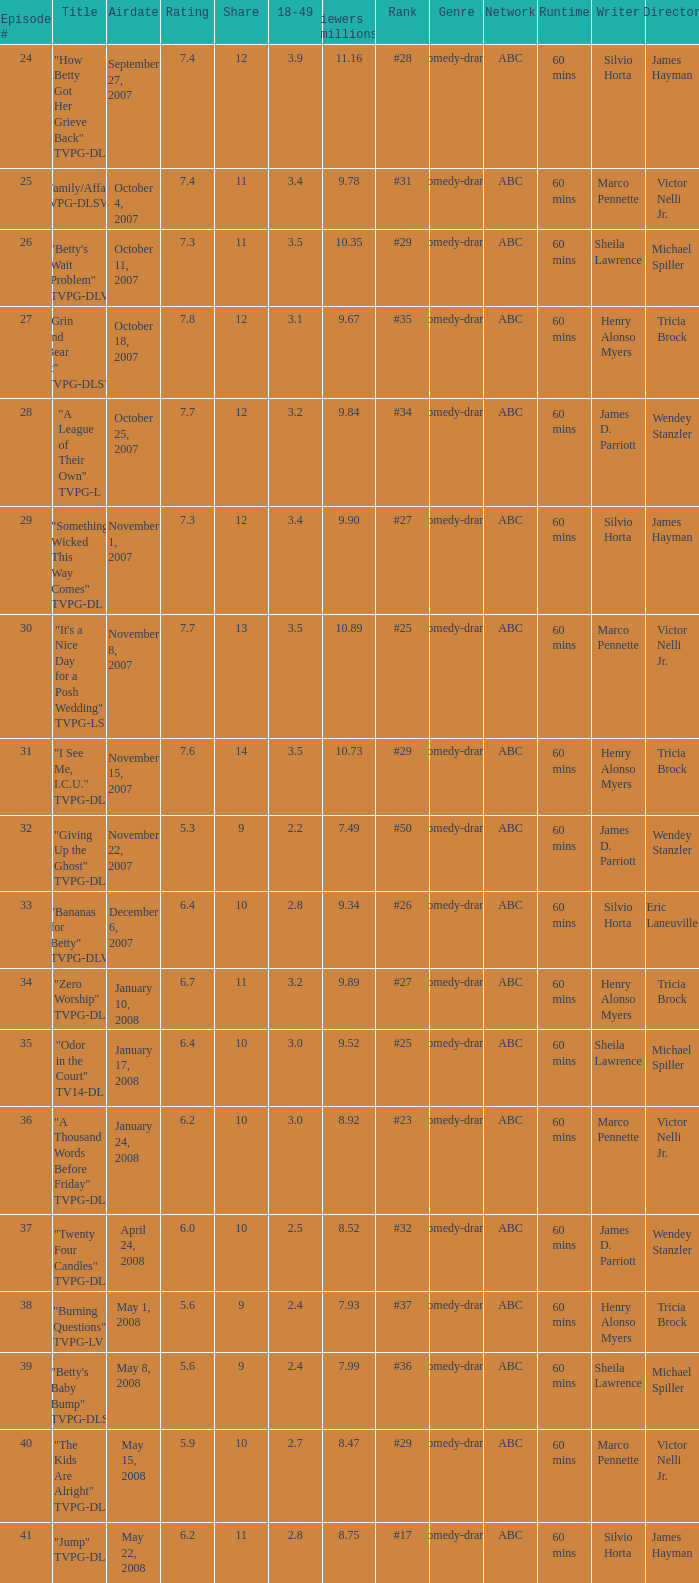What is the Airdate of the episode that ranked #29 and had a share greater than 10? May 15, 2008. 